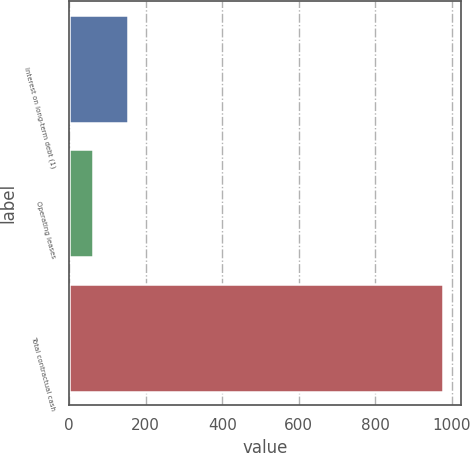<chart> <loc_0><loc_0><loc_500><loc_500><bar_chart><fcel>Interest on long-term debt (1)<fcel>Operating leases<fcel>Total contractual cash<nl><fcel>153.4<fcel>62<fcel>976<nl></chart> 